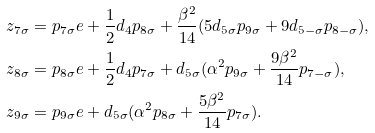<formula> <loc_0><loc_0><loc_500><loc_500>& z _ { 7 \sigma } = p _ { 7 \sigma } e + \frac { 1 } { 2 } d _ { 4 } p _ { 8 \sigma } + \frac { \beta ^ { 2 } } { 1 4 } ( 5 d _ { 5 \sigma } p _ { 9 \sigma } + 9 d _ { 5 - \sigma } p _ { 8 - \sigma } ) , \\ & z _ { 8 \sigma } = p _ { 8 \sigma } e + \frac { 1 } { 2 } d _ { 4 } p _ { 7 \sigma } + d _ { 5 \sigma } ( \alpha ^ { 2 } p _ { 9 \sigma } + \frac { 9 \beta ^ { 2 } } { 1 4 } p _ { 7 - \sigma } ) , \\ & z _ { 9 \sigma } = p _ { 9 \sigma } e + d _ { 5 \sigma } ( \alpha ^ { 2 } p _ { 8 \sigma } + \frac { 5 \beta ^ { 2 } } { 1 4 } p _ { 7 \sigma } ) .</formula> 